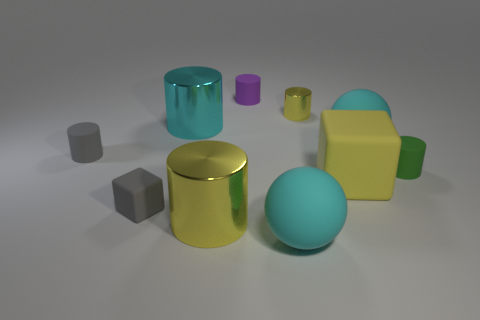Does the small metallic object have the same color as the cylinder that is in front of the large yellow rubber block?
Offer a very short reply. Yes. What is the material of the small thing that is the same color as the big rubber cube?
Offer a very short reply. Metal. Is there a large matte object that has the same shape as the big yellow metallic thing?
Your response must be concise. No. There is a big block; how many gray things are in front of it?
Offer a very short reply. 1. What material is the big sphere that is behind the cyan ball in front of the gray cube?
Your answer should be compact. Rubber. There is a cyan cylinder that is the same size as the yellow block; what is its material?
Provide a succinct answer. Metal. Are there any green rubber things of the same size as the green cylinder?
Keep it short and to the point. No. What color is the matte cylinder that is to the left of the purple cylinder?
Your answer should be very brief. Gray. Are there any tiny cylinders that are in front of the big metallic cylinder that is behind the tiny green matte thing?
Provide a short and direct response. Yes. What number of other things are there of the same color as the tiny metal object?
Ensure brevity in your answer.  2. 